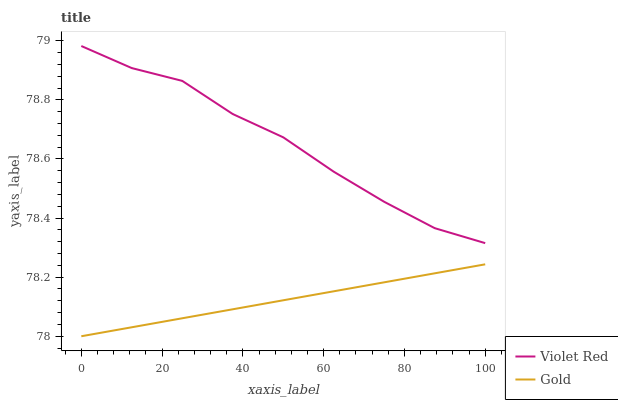Does Gold have the minimum area under the curve?
Answer yes or no. Yes. Does Violet Red have the maximum area under the curve?
Answer yes or no. Yes. Does Gold have the maximum area under the curve?
Answer yes or no. No. Is Gold the smoothest?
Answer yes or no. Yes. Is Violet Red the roughest?
Answer yes or no. Yes. Is Gold the roughest?
Answer yes or no. No. Does Gold have the lowest value?
Answer yes or no. Yes. Does Violet Red have the highest value?
Answer yes or no. Yes. Does Gold have the highest value?
Answer yes or no. No. Is Gold less than Violet Red?
Answer yes or no. Yes. Is Violet Red greater than Gold?
Answer yes or no. Yes. Does Gold intersect Violet Red?
Answer yes or no. No. 